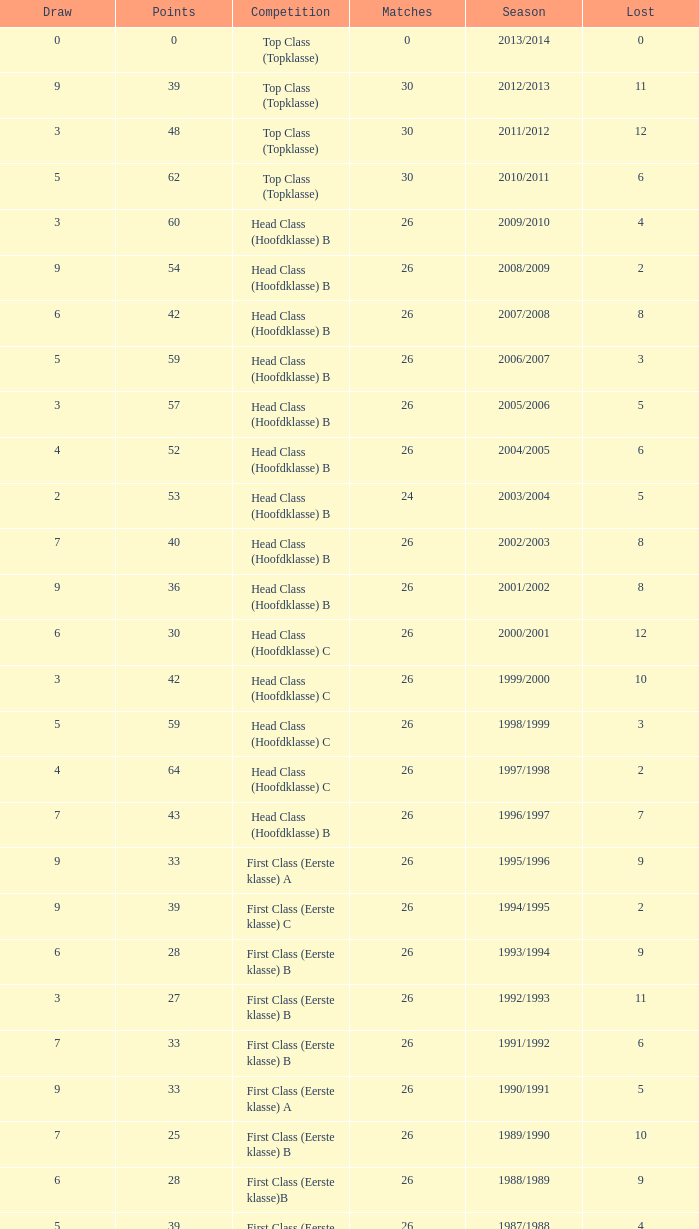What competition has a score greater than 30, a draw less than 5, and a loss larger than 10? Top Class (Topklasse). 